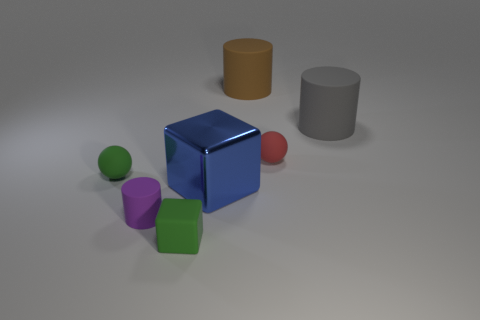What number of red balls are behind the small sphere behind the tiny green matte sphere?
Offer a terse response. 0. What is the material of the large thing that is in front of the big brown cylinder and left of the big gray rubber object?
Make the answer very short. Metal. The red rubber object that is the same size as the purple rubber cylinder is what shape?
Ensure brevity in your answer.  Sphere. There is a large matte thing that is on the right side of the sphere to the right of the cylinder in front of the large blue thing; what color is it?
Make the answer very short. Gray. What number of things are either objects in front of the small purple cylinder or tiny red spheres?
Make the answer very short. 2. What is the material of the gray cylinder that is the same size as the blue metallic block?
Provide a short and direct response. Rubber. The tiny cylinder on the left side of the large object that is in front of the large rubber object in front of the big brown rubber cylinder is made of what material?
Provide a short and direct response. Rubber. What is the color of the large cube?
Keep it short and to the point. Blue. What number of big objects are either balls or red things?
Keep it short and to the point. 0. What material is the object that is the same color as the matte block?
Ensure brevity in your answer.  Rubber. 